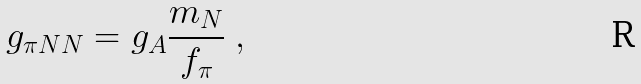<formula> <loc_0><loc_0><loc_500><loc_500>g _ { \pi N N } = g _ { A } \frac { m _ { N } } { f _ { \pi } } \ ,</formula> 